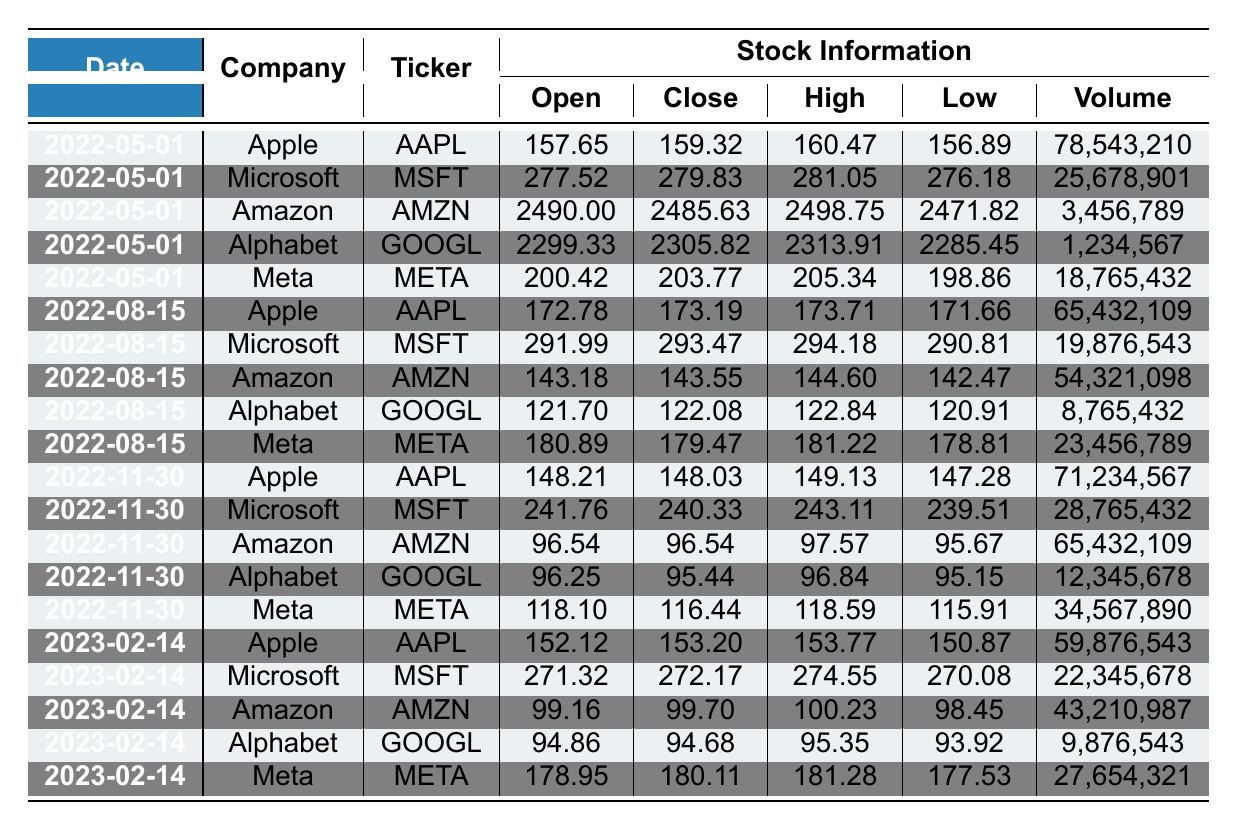What is the closing price of Apple on May 1, 2022? Referring to the entry for Apple on May 1, 2022, the closing price is listed in the table as 159.32.
Answer: 159.32 What was the highest stock price for Amazon on August 15, 2022? Looking at Amazon's stock information for August 15, 2022, the highest price is listed as 144.60.
Answer: 144.60 What was the trading volume for Microsoft on November 30, 2022? The trading volume for Microsoft on November 30, 2022, is found in the corresponding row, and it is 28,765,432.
Answer: 28,765,432 Did Alphabet's stock price increase from the opening price to the closing price on May 1, 2022? The opening price for Alphabet on May 1, 2022, is 2299.33 and the closing price is 2305.82. Since 2305.82 is greater than 2299.33, this indicates an increase.
Answer: Yes What is the average closing price for Meta over the entire dataset? First, we extract the closing prices for Meta: 203.77, 179.47, 116.44, 180.11. Then, we sum these values: 203.77 + 179.47 + 116.44 + 180.11 = 679.79. Since there are 4 entries, we calculate the average as 679.79 / 4 = 169.9475 (rounded to 169.95).
Answer: 169.95 Which company had the highest opening price on February 14, 2023? Review the open prices on February 14, 2023, where Apple is 152.12, Microsoft is 271.32, Amazon is 99.16, Alphabet is 94.86, and Meta is 178.95. The highest opening price is for Microsoft at 271.32.
Answer: Microsoft What was the percentage change in the closing price of Amazon from May 1, 2022, to August 15, 2022? The closing price of Amazon on May 1, 2022, is 2485.63 and on August 15, 2022, it is 143.55. We find the difference: 143.55 - 2485.63 = -2342.08. The percentage change is (-2342.08 / 2485.63) * 100 ≈ -94.25%.
Answer: -94.25% What was the lowest closing price for Alphabet throughout the listed dates? We check all the closing prices for Alphabet: 2305.82, 122.08, 95.44, and 94.68. The lowest value is 94.68.
Answer: 94.68 How many times did Apple's closing price exceed 150 over the recorded dates? Looking at the closing prices for Apple: 159.32, 173.19, 148.03, and 153.20, we see that 159.32, 173.19, and 153.20 are all greater than 150, making it 3 occurrences.
Answer: 3 Is the average trading volume for Amazon higher in the first half of the year compared to the second half of the year? For Amazon in the first half: May 1, 2022 (3,456,789) and August 15, 2022 (54,321,098), sum = 57,777,887. Average = 28,888,943.5. For the second half of the year: November 30, 2022 (65,432,109) and February 14, 2023 (43,210,987), sum = 108,643,096. Average = 54,321,548. Since 28,888,943.5 < 54,321,548, Amazon's second half volume is higher.
Answer: No 